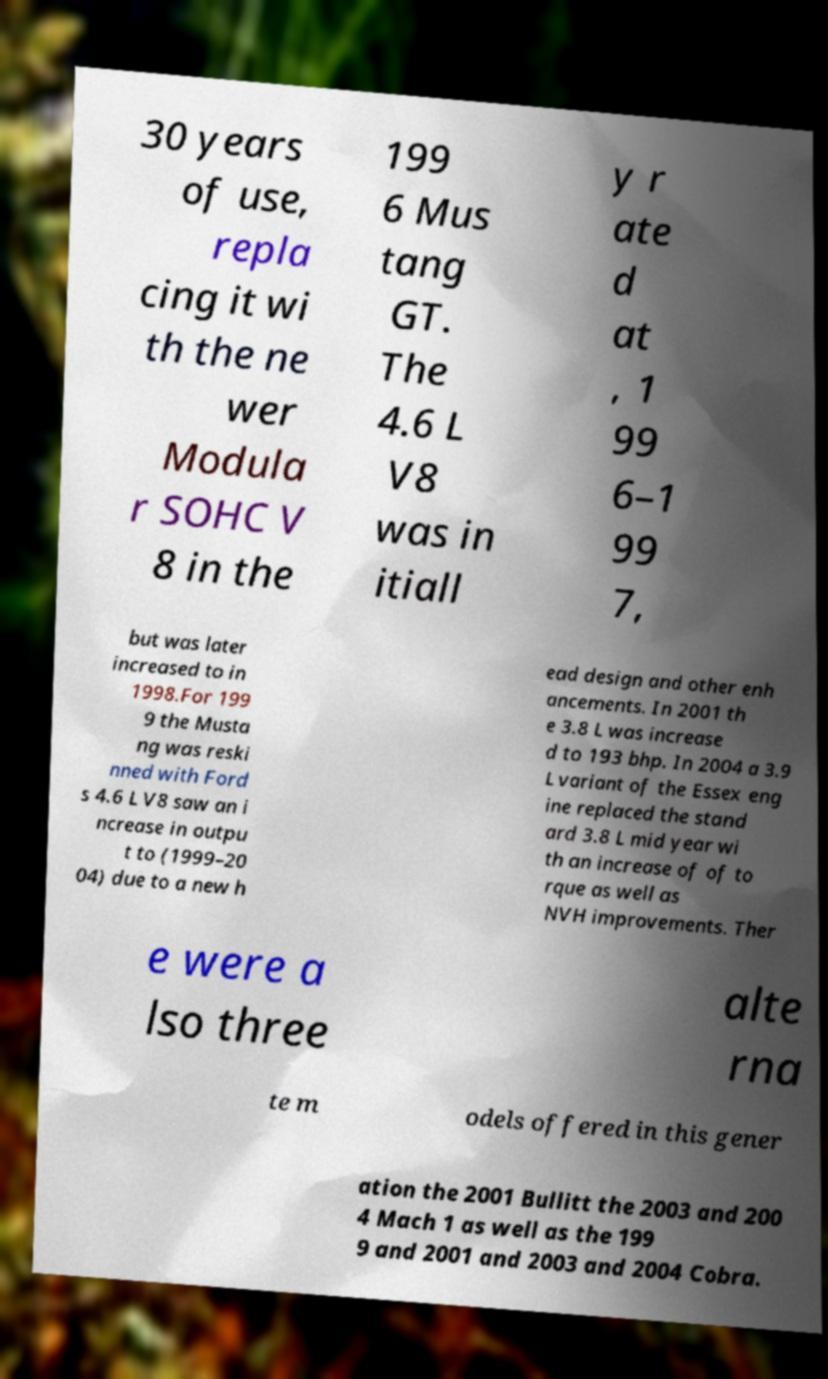Could you extract and type out the text from this image? 30 years of use, repla cing it wi th the ne wer Modula r SOHC V 8 in the 199 6 Mus tang GT. The 4.6 L V8 was in itiall y r ate d at , 1 99 6–1 99 7, but was later increased to in 1998.For 199 9 the Musta ng was reski nned with Ford s 4.6 L V8 saw an i ncrease in outpu t to (1999–20 04) due to a new h ead design and other enh ancements. In 2001 th e 3.8 L was increase d to 193 bhp. In 2004 a 3.9 L variant of the Essex eng ine replaced the stand ard 3.8 L mid year wi th an increase of of to rque as well as NVH improvements. Ther e were a lso three alte rna te m odels offered in this gener ation the 2001 Bullitt the 2003 and 200 4 Mach 1 as well as the 199 9 and 2001 and 2003 and 2004 Cobra. 